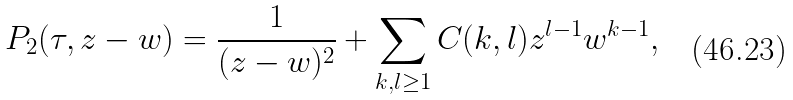<formula> <loc_0><loc_0><loc_500><loc_500>P _ { 2 } ( \tau , z - w ) = \frac { 1 } { ( z - w ) ^ { 2 } } + \sum _ { k , l \geq 1 } C ( k , l ) z ^ { l - 1 } w ^ { k - 1 } ,</formula> 